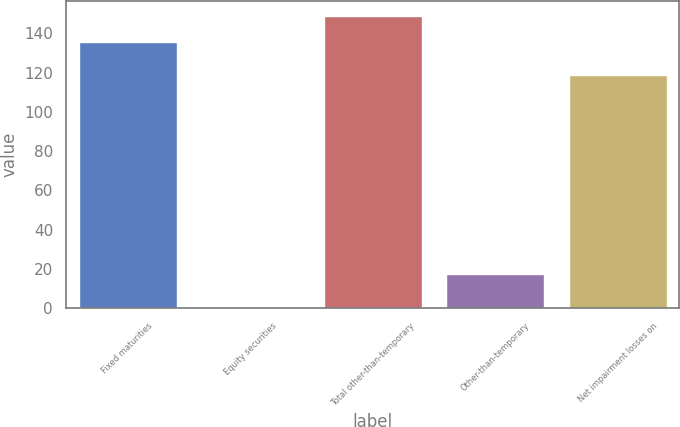Convert chart. <chart><loc_0><loc_0><loc_500><loc_500><bar_chart><fcel>Fixed maturities<fcel>Equity securities<fcel>Total other-than-temporary<fcel>Other-than-temporary<fcel>Net impairment losses on<nl><fcel>135.5<fcel>0.4<fcel>149.05<fcel>17.3<fcel>118.6<nl></chart> 